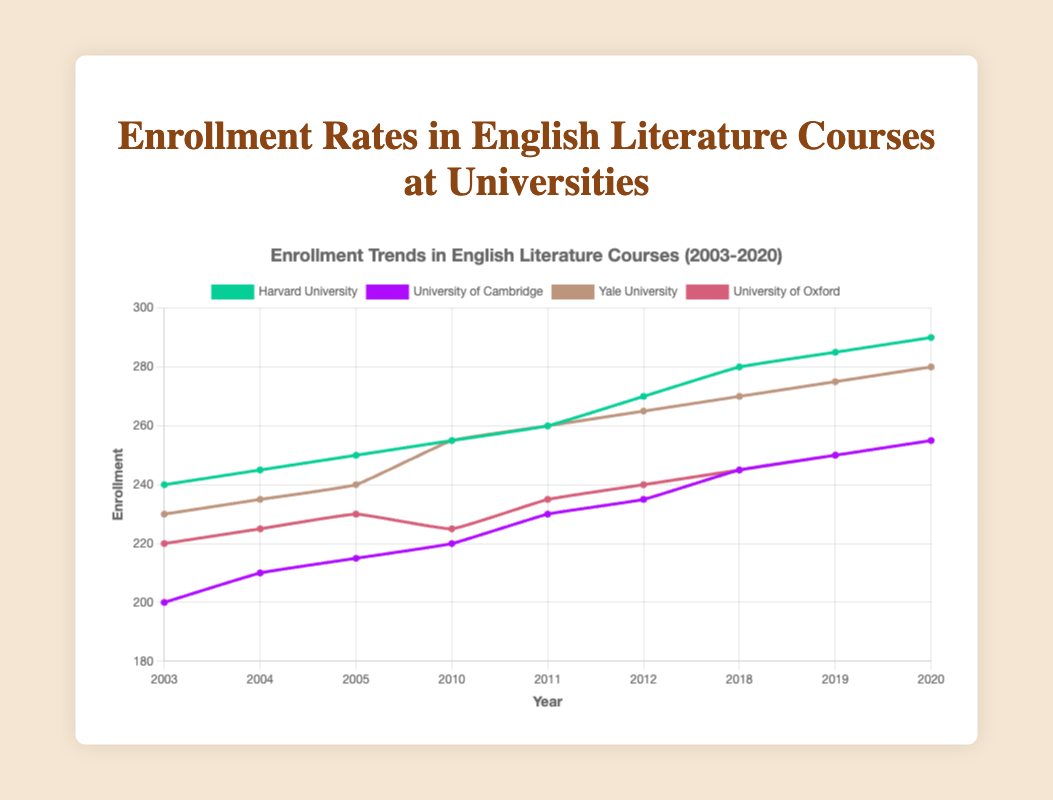What is the enrollment rate for Harvard University in 2020? The plot shows a line for Harvard University, and at the year 2020, the value is at 290.
Answer: 290 Which university had the highest enrollment rate in 2005? We look at the year 2005 in the plot and compare the values for each university. Yale University has the highest enrollment at 240.
Answer: Yale University What is the average enrollment rate for University of Cambridge over the years 2003, 2004, and 2005? Add the enrollment rates for 2003 (200), 2004 (210), and 2005 (215), then divide by 3. (200 + 210 + 215) / 3 = 625 / 3 = approximately 208.3
Answer: 208.3 Which university shows the steepest increase in enrollment between 2019 and 2020? Compare the slopes of the lines from 2019 to 2020. Harvard University goes from 285 to 290, University of Cambridge from 250 to 255, Yale University from 275 to 280, and University of Oxford from 250 to 255. They all increase by 5. Therefore, there is no single university with a steeper increase.
Answer: All universities increased equally Is the enrollment trend for Yale University consistent? We check the Yale University line from 2003 to 2020. The enrollment rate consistently increases each year without any drops.
Answer: Yes What is the difference in enrollment rates between University of Oxford and University of Cambridge in the year 2018? In 2018, University of Oxford has 245 enrollments and University of Cambridge has 245 enrollments. The difference is 245 - 245 = 0.
Answer: 0 Between Harvard University and Yale University, which had a greater increase in enrollment from 2011 to 2012? For Harvard University, the increase from 2011 to 2012 is from 260 to 270 (10 units). For Yale University, it is from 260 to 265 (5 units). Therefore, Harvard had a greater increase.
Answer: Harvard University What was the general trend in enrollment rates for University of Oxford from 2003 to 2020? By observing the line for University of Oxford, it steadily increases from 220 in 2003 to 255 in 2020, showing a positive trend.
Answer: Increasing Calculate the total enrollment rates combined for all the universities in 2020. Add the enrollment rates of all four universities in 2020: Harvard University (290) + University of Cambridge (255) + Yale University (280) + University of Oxford (255). The total is 290 + 255 + 280 + 255 = 1080.
Answer: 1080 